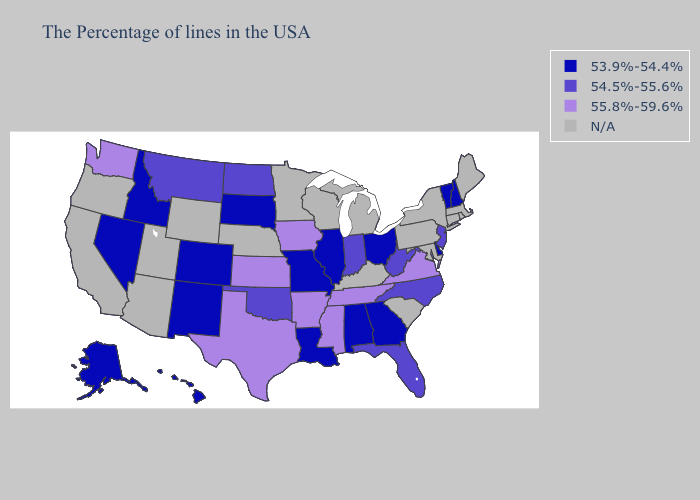What is the value of Ohio?
Be succinct. 53.9%-54.4%. Does Texas have the highest value in the USA?
Keep it brief. Yes. What is the highest value in the MidWest ?
Be succinct. 55.8%-59.6%. Name the states that have a value in the range 53.9%-54.4%?
Keep it brief. New Hampshire, Vermont, Delaware, Ohio, Georgia, Alabama, Illinois, Louisiana, Missouri, South Dakota, Colorado, New Mexico, Idaho, Nevada, Alaska, Hawaii. Which states have the lowest value in the USA?
Short answer required. New Hampshire, Vermont, Delaware, Ohio, Georgia, Alabama, Illinois, Louisiana, Missouri, South Dakota, Colorado, New Mexico, Idaho, Nevada, Alaska, Hawaii. What is the highest value in states that border California?
Give a very brief answer. 53.9%-54.4%. Among the states that border North Carolina , does Georgia have the highest value?
Concise answer only. No. Does Vermont have the highest value in the Northeast?
Keep it brief. No. Which states have the highest value in the USA?
Short answer required. Virginia, Tennessee, Mississippi, Arkansas, Iowa, Kansas, Texas, Washington. What is the value of Connecticut?
Be succinct. N/A. Which states hav the highest value in the Northeast?
Keep it brief. New Jersey. Name the states that have a value in the range 55.8%-59.6%?
Be succinct. Virginia, Tennessee, Mississippi, Arkansas, Iowa, Kansas, Texas, Washington. What is the value of Texas?
Give a very brief answer. 55.8%-59.6%. Does Kansas have the highest value in the USA?
Keep it brief. Yes. 